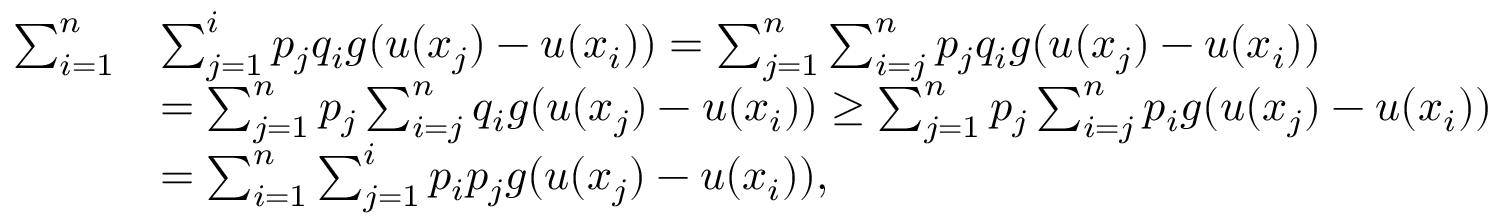Convert formula to latex. <formula><loc_0><loc_0><loc_500><loc_500>\begin{array} { r l } { \sum _ { i = 1 } ^ { n } } & { \sum _ { j = 1 } ^ { i } p _ { j } q _ { i } g ( u ( x _ { j } ) - u ( x _ { i } ) ) = \sum _ { j = 1 } ^ { n } \sum _ { i = j } ^ { n } p _ { j } q _ { i } g ( u ( x _ { j } ) - u ( x _ { i } ) ) } \\ & { = \sum _ { j = 1 } ^ { n } p _ { j } \sum _ { i = j } ^ { n } q _ { i } g ( u ( x _ { j } ) - u ( x _ { i } ) ) \geq \sum _ { j = 1 } ^ { n } p _ { j } \sum _ { i = j } ^ { n } p _ { i } g ( u ( x _ { j } ) - u ( x _ { i } ) ) } \\ & { = \sum _ { i = 1 } ^ { n } \sum _ { j = 1 } ^ { i } p _ { i } p _ { j } g ( u ( x _ { j } ) - u ( x _ { i } ) ) , } \end{array}</formula> 